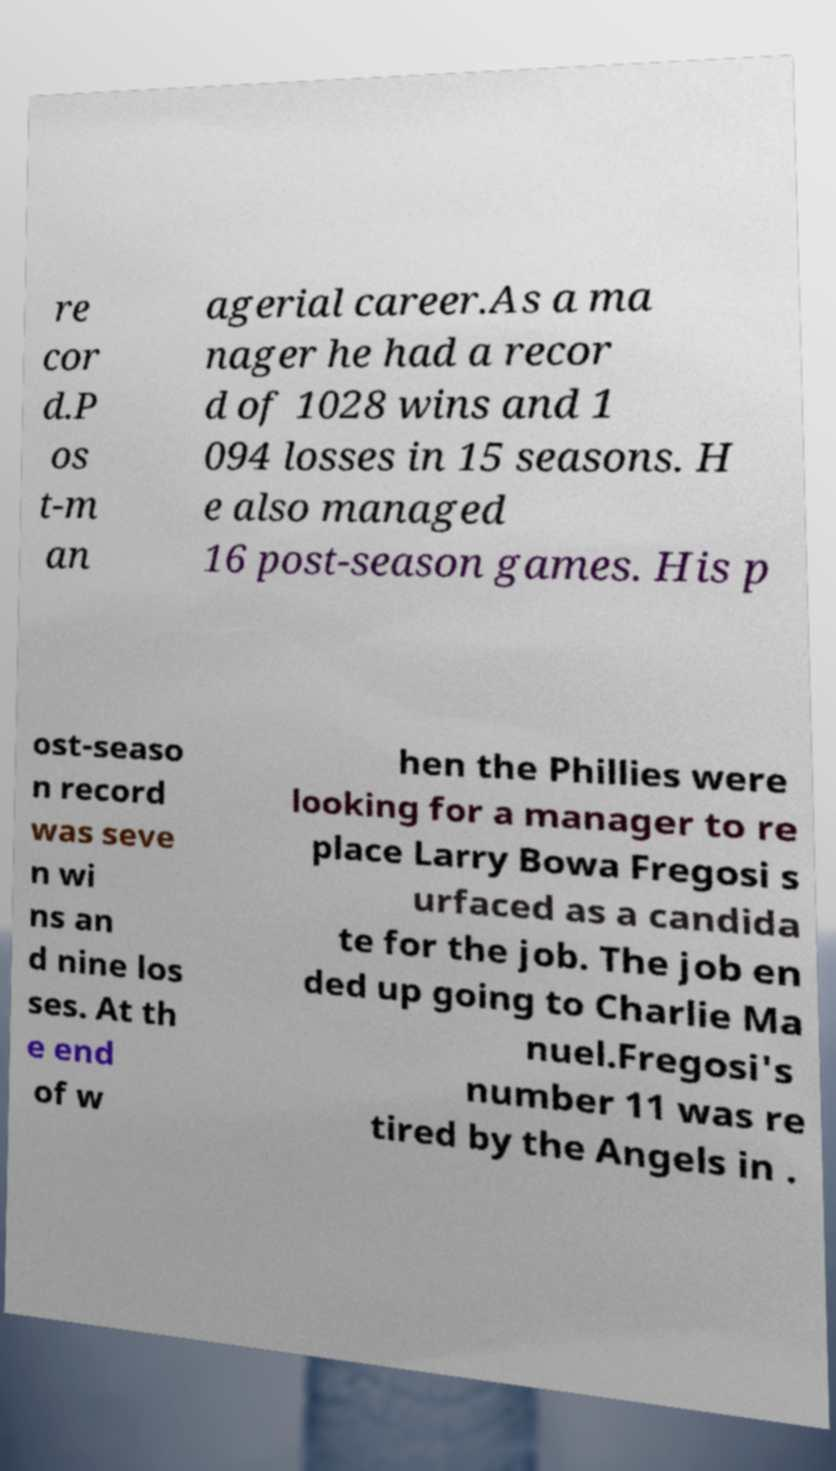I need the written content from this picture converted into text. Can you do that? re cor d.P os t-m an agerial career.As a ma nager he had a recor d of 1028 wins and 1 094 losses in 15 seasons. H e also managed 16 post-season games. His p ost-seaso n record was seve n wi ns an d nine los ses. At th e end of w hen the Phillies were looking for a manager to re place Larry Bowa Fregosi s urfaced as a candida te for the job. The job en ded up going to Charlie Ma nuel.Fregosi's number 11 was re tired by the Angels in . 